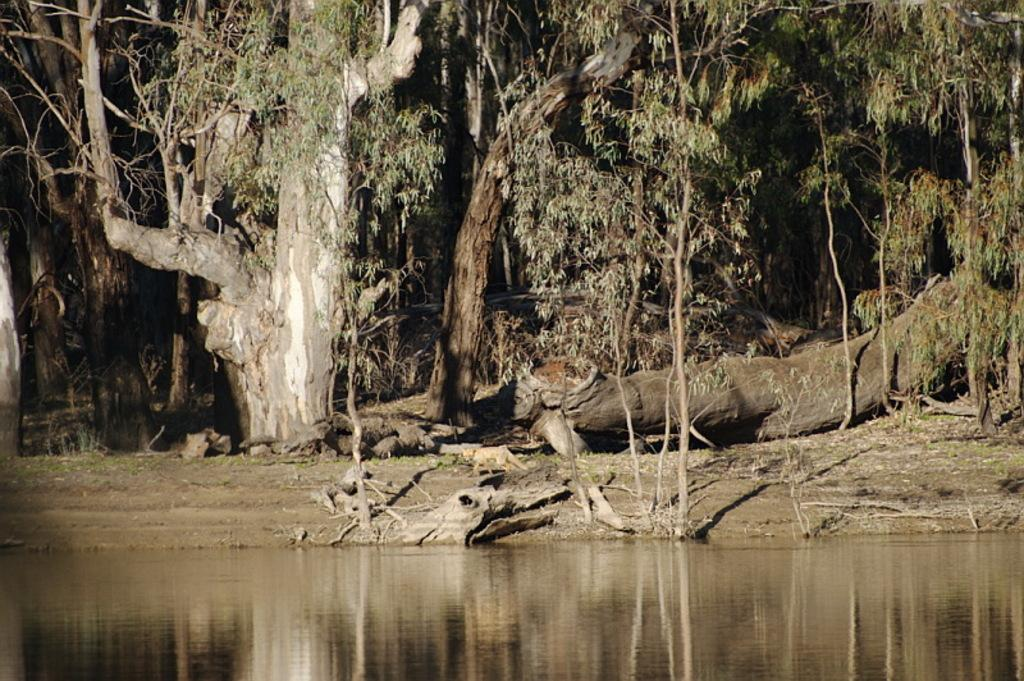What type of natural environment can be seen in the background of the image? There are trees in the background of the image. What is visible at the bottom of the image? There is water visible at the bottom of the image. What type of silk material is draped over the trees in the image? There is no silk material present in the image; it features trees in the background and water at the bottom. What rhythm is being played in the background of the image? There is no music or rhythm present in the image; it only shows trees and water. 